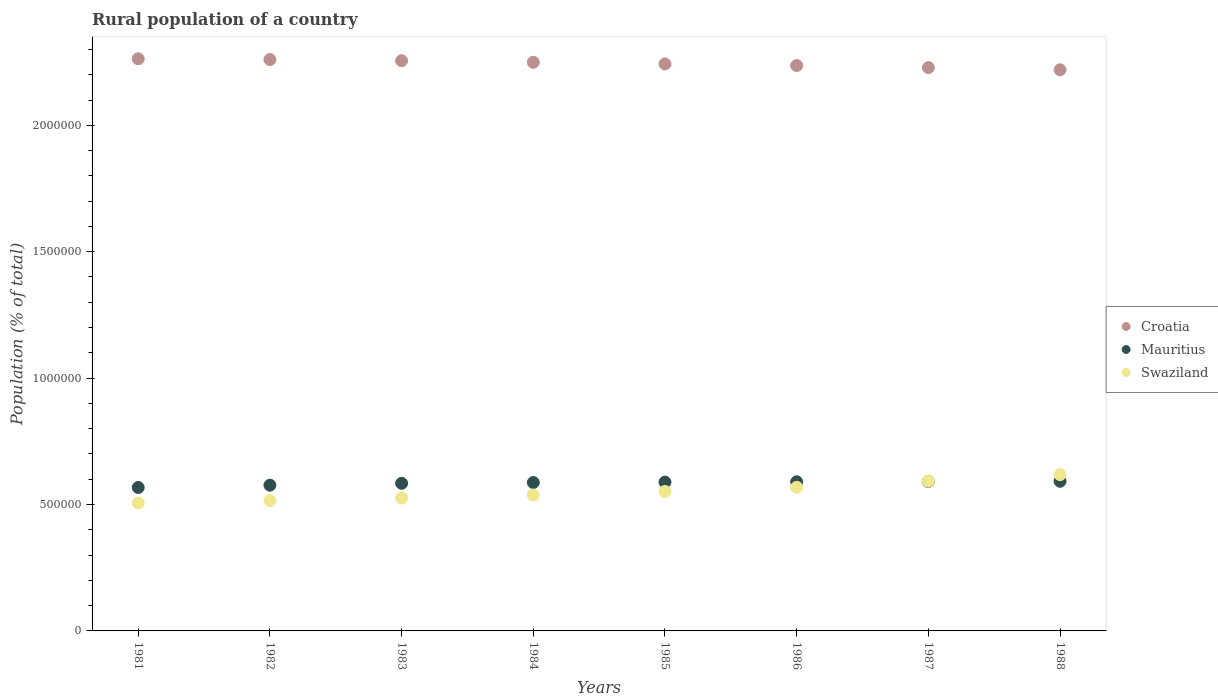How many different coloured dotlines are there?
Offer a terse response. 3. Is the number of dotlines equal to the number of legend labels?
Keep it short and to the point. Yes. What is the rural population in Mauritius in 1986?
Provide a short and direct response. 5.90e+05. Across all years, what is the maximum rural population in Swaziland?
Your answer should be compact. 6.18e+05. Across all years, what is the minimum rural population in Croatia?
Your answer should be very brief. 2.22e+06. In which year was the rural population in Swaziland maximum?
Offer a terse response. 1988. What is the total rural population in Swaziland in the graph?
Give a very brief answer. 4.42e+06. What is the difference between the rural population in Swaziland in 1982 and that in 1986?
Ensure brevity in your answer.  -5.27e+04. What is the difference between the rural population in Croatia in 1985 and the rural population in Mauritius in 1987?
Offer a very short reply. 1.65e+06. What is the average rural population in Croatia per year?
Offer a terse response. 2.24e+06. In the year 1985, what is the difference between the rural population in Croatia and rural population in Mauritius?
Provide a short and direct response. 1.65e+06. In how many years, is the rural population in Mauritius greater than 300000 %?
Offer a very short reply. 8. What is the ratio of the rural population in Swaziland in 1984 to that in 1988?
Give a very brief answer. 0.87. Is the rural population in Croatia in 1983 less than that in 1986?
Offer a terse response. No. What is the difference between the highest and the second highest rural population in Swaziland?
Make the answer very short. 2.60e+04. What is the difference between the highest and the lowest rural population in Swaziland?
Ensure brevity in your answer.  1.12e+05. In how many years, is the rural population in Croatia greater than the average rural population in Croatia taken over all years?
Offer a terse response. 4. Does the rural population in Croatia monotonically increase over the years?
Make the answer very short. No. Is the rural population in Croatia strictly greater than the rural population in Swaziland over the years?
Your answer should be compact. Yes. Is the rural population in Croatia strictly less than the rural population in Swaziland over the years?
Your response must be concise. No. Are the values on the major ticks of Y-axis written in scientific E-notation?
Offer a very short reply. No. Does the graph contain any zero values?
Offer a terse response. No. Does the graph contain grids?
Provide a short and direct response. No. How are the legend labels stacked?
Ensure brevity in your answer.  Vertical. What is the title of the graph?
Your answer should be very brief. Rural population of a country. What is the label or title of the X-axis?
Ensure brevity in your answer.  Years. What is the label or title of the Y-axis?
Make the answer very short. Population (% of total). What is the Population (% of total) in Croatia in 1981?
Offer a very short reply. 2.26e+06. What is the Population (% of total) in Mauritius in 1981?
Keep it short and to the point. 5.67e+05. What is the Population (% of total) in Swaziland in 1981?
Your answer should be compact. 5.06e+05. What is the Population (% of total) of Croatia in 1982?
Offer a very short reply. 2.26e+06. What is the Population (% of total) in Mauritius in 1982?
Ensure brevity in your answer.  5.76e+05. What is the Population (% of total) in Swaziland in 1982?
Your answer should be compact. 5.16e+05. What is the Population (% of total) in Croatia in 1983?
Ensure brevity in your answer.  2.26e+06. What is the Population (% of total) in Mauritius in 1983?
Make the answer very short. 5.84e+05. What is the Population (% of total) in Swaziland in 1983?
Provide a succinct answer. 5.26e+05. What is the Population (% of total) in Croatia in 1984?
Offer a terse response. 2.25e+06. What is the Population (% of total) of Mauritius in 1984?
Keep it short and to the point. 5.87e+05. What is the Population (% of total) in Swaziland in 1984?
Your answer should be very brief. 5.38e+05. What is the Population (% of total) in Croatia in 1985?
Offer a terse response. 2.24e+06. What is the Population (% of total) in Mauritius in 1985?
Make the answer very short. 5.89e+05. What is the Population (% of total) of Swaziland in 1985?
Give a very brief answer. 5.52e+05. What is the Population (% of total) of Croatia in 1986?
Give a very brief answer. 2.24e+06. What is the Population (% of total) of Mauritius in 1986?
Offer a terse response. 5.90e+05. What is the Population (% of total) in Swaziland in 1986?
Your answer should be compact. 5.68e+05. What is the Population (% of total) of Croatia in 1987?
Your answer should be very brief. 2.23e+06. What is the Population (% of total) of Mauritius in 1987?
Offer a terse response. 5.91e+05. What is the Population (% of total) in Swaziland in 1987?
Your answer should be compact. 5.92e+05. What is the Population (% of total) in Croatia in 1988?
Make the answer very short. 2.22e+06. What is the Population (% of total) of Mauritius in 1988?
Make the answer very short. 5.92e+05. What is the Population (% of total) of Swaziland in 1988?
Keep it short and to the point. 6.18e+05. Across all years, what is the maximum Population (% of total) in Croatia?
Your response must be concise. 2.26e+06. Across all years, what is the maximum Population (% of total) in Mauritius?
Your answer should be compact. 5.92e+05. Across all years, what is the maximum Population (% of total) of Swaziland?
Provide a succinct answer. 6.18e+05. Across all years, what is the minimum Population (% of total) in Croatia?
Give a very brief answer. 2.22e+06. Across all years, what is the minimum Population (% of total) of Mauritius?
Offer a terse response. 5.67e+05. Across all years, what is the minimum Population (% of total) of Swaziland?
Your answer should be very brief. 5.06e+05. What is the total Population (% of total) of Croatia in the graph?
Offer a very short reply. 1.80e+07. What is the total Population (% of total) of Mauritius in the graph?
Provide a succinct answer. 4.68e+06. What is the total Population (% of total) of Swaziland in the graph?
Your response must be concise. 4.42e+06. What is the difference between the Population (% of total) in Croatia in 1981 and that in 1982?
Ensure brevity in your answer.  3009. What is the difference between the Population (% of total) in Mauritius in 1981 and that in 1982?
Provide a succinct answer. -9132. What is the difference between the Population (% of total) of Swaziland in 1981 and that in 1982?
Your response must be concise. -9759. What is the difference between the Population (% of total) in Croatia in 1981 and that in 1983?
Your answer should be compact. 7659. What is the difference between the Population (% of total) of Mauritius in 1981 and that in 1983?
Your answer should be very brief. -1.66e+04. What is the difference between the Population (% of total) of Swaziland in 1981 and that in 1983?
Offer a very short reply. -2.00e+04. What is the difference between the Population (% of total) of Croatia in 1981 and that in 1984?
Your response must be concise. 1.39e+04. What is the difference between the Population (% of total) of Mauritius in 1981 and that in 1984?
Offer a very short reply. -1.96e+04. What is the difference between the Population (% of total) of Swaziland in 1981 and that in 1984?
Offer a terse response. -3.18e+04. What is the difference between the Population (% of total) in Croatia in 1981 and that in 1985?
Your answer should be very brief. 2.03e+04. What is the difference between the Population (% of total) of Mauritius in 1981 and that in 1985?
Your answer should be very brief. -2.12e+04. What is the difference between the Population (% of total) in Swaziland in 1981 and that in 1985?
Provide a succinct answer. -4.58e+04. What is the difference between the Population (% of total) of Croatia in 1981 and that in 1986?
Your answer should be very brief. 2.68e+04. What is the difference between the Population (% of total) of Mauritius in 1981 and that in 1986?
Provide a short and direct response. -2.25e+04. What is the difference between the Population (% of total) in Swaziland in 1981 and that in 1986?
Your answer should be very brief. -6.24e+04. What is the difference between the Population (% of total) in Croatia in 1981 and that in 1987?
Your response must be concise. 3.49e+04. What is the difference between the Population (% of total) of Mauritius in 1981 and that in 1987?
Offer a very short reply. -2.37e+04. What is the difference between the Population (% of total) of Swaziland in 1981 and that in 1987?
Give a very brief answer. -8.64e+04. What is the difference between the Population (% of total) in Croatia in 1981 and that in 1988?
Offer a terse response. 4.35e+04. What is the difference between the Population (% of total) of Mauritius in 1981 and that in 1988?
Your answer should be very brief. -2.45e+04. What is the difference between the Population (% of total) of Swaziland in 1981 and that in 1988?
Provide a short and direct response. -1.12e+05. What is the difference between the Population (% of total) of Croatia in 1982 and that in 1983?
Keep it short and to the point. 4650. What is the difference between the Population (% of total) of Mauritius in 1982 and that in 1983?
Keep it short and to the point. -7490. What is the difference between the Population (% of total) in Swaziland in 1982 and that in 1983?
Your response must be concise. -1.02e+04. What is the difference between the Population (% of total) of Croatia in 1982 and that in 1984?
Make the answer very short. 1.09e+04. What is the difference between the Population (% of total) of Mauritius in 1982 and that in 1984?
Keep it short and to the point. -1.05e+04. What is the difference between the Population (% of total) of Swaziland in 1982 and that in 1984?
Provide a succinct answer. -2.21e+04. What is the difference between the Population (% of total) of Croatia in 1982 and that in 1985?
Ensure brevity in your answer.  1.73e+04. What is the difference between the Population (% of total) of Mauritius in 1982 and that in 1985?
Provide a succinct answer. -1.21e+04. What is the difference between the Population (% of total) of Swaziland in 1982 and that in 1985?
Ensure brevity in your answer.  -3.61e+04. What is the difference between the Population (% of total) of Croatia in 1982 and that in 1986?
Offer a terse response. 2.38e+04. What is the difference between the Population (% of total) in Mauritius in 1982 and that in 1986?
Offer a terse response. -1.34e+04. What is the difference between the Population (% of total) in Swaziland in 1982 and that in 1986?
Offer a terse response. -5.27e+04. What is the difference between the Population (% of total) of Croatia in 1982 and that in 1987?
Your answer should be very brief. 3.18e+04. What is the difference between the Population (% of total) of Mauritius in 1982 and that in 1987?
Make the answer very short. -1.46e+04. What is the difference between the Population (% of total) in Swaziland in 1982 and that in 1987?
Keep it short and to the point. -7.67e+04. What is the difference between the Population (% of total) in Croatia in 1982 and that in 1988?
Offer a very short reply. 4.05e+04. What is the difference between the Population (% of total) in Mauritius in 1982 and that in 1988?
Offer a terse response. -1.54e+04. What is the difference between the Population (% of total) in Swaziland in 1982 and that in 1988?
Your response must be concise. -1.03e+05. What is the difference between the Population (% of total) of Croatia in 1983 and that in 1984?
Your answer should be compact. 6261. What is the difference between the Population (% of total) in Mauritius in 1983 and that in 1984?
Keep it short and to the point. -2991. What is the difference between the Population (% of total) of Swaziland in 1983 and that in 1984?
Your answer should be compact. -1.18e+04. What is the difference between the Population (% of total) of Croatia in 1983 and that in 1985?
Provide a succinct answer. 1.26e+04. What is the difference between the Population (% of total) in Mauritius in 1983 and that in 1985?
Keep it short and to the point. -4614. What is the difference between the Population (% of total) of Swaziland in 1983 and that in 1985?
Keep it short and to the point. -2.59e+04. What is the difference between the Population (% of total) in Croatia in 1983 and that in 1986?
Provide a succinct answer. 1.91e+04. What is the difference between the Population (% of total) in Mauritius in 1983 and that in 1986?
Offer a terse response. -5902. What is the difference between the Population (% of total) in Swaziland in 1983 and that in 1986?
Offer a terse response. -4.24e+04. What is the difference between the Population (% of total) of Croatia in 1983 and that in 1987?
Offer a terse response. 2.72e+04. What is the difference between the Population (% of total) in Mauritius in 1983 and that in 1987?
Your answer should be very brief. -7078. What is the difference between the Population (% of total) in Swaziland in 1983 and that in 1987?
Your answer should be compact. -6.64e+04. What is the difference between the Population (% of total) of Croatia in 1983 and that in 1988?
Make the answer very short. 3.59e+04. What is the difference between the Population (% of total) of Mauritius in 1983 and that in 1988?
Make the answer very short. -7864. What is the difference between the Population (% of total) in Swaziland in 1983 and that in 1988?
Offer a terse response. -9.24e+04. What is the difference between the Population (% of total) of Croatia in 1984 and that in 1985?
Make the answer very short. 6361. What is the difference between the Population (% of total) of Mauritius in 1984 and that in 1985?
Offer a terse response. -1623. What is the difference between the Population (% of total) of Swaziland in 1984 and that in 1985?
Ensure brevity in your answer.  -1.40e+04. What is the difference between the Population (% of total) of Croatia in 1984 and that in 1986?
Offer a terse response. 1.29e+04. What is the difference between the Population (% of total) in Mauritius in 1984 and that in 1986?
Your answer should be compact. -2911. What is the difference between the Population (% of total) in Swaziland in 1984 and that in 1986?
Provide a succinct answer. -3.06e+04. What is the difference between the Population (% of total) of Croatia in 1984 and that in 1987?
Your answer should be very brief. 2.09e+04. What is the difference between the Population (% of total) in Mauritius in 1984 and that in 1987?
Offer a terse response. -4087. What is the difference between the Population (% of total) in Swaziland in 1984 and that in 1987?
Make the answer very short. -5.46e+04. What is the difference between the Population (% of total) of Croatia in 1984 and that in 1988?
Keep it short and to the point. 2.96e+04. What is the difference between the Population (% of total) in Mauritius in 1984 and that in 1988?
Your answer should be compact. -4873. What is the difference between the Population (% of total) of Swaziland in 1984 and that in 1988?
Provide a short and direct response. -8.06e+04. What is the difference between the Population (% of total) in Croatia in 1985 and that in 1986?
Keep it short and to the point. 6508. What is the difference between the Population (% of total) in Mauritius in 1985 and that in 1986?
Keep it short and to the point. -1288. What is the difference between the Population (% of total) in Swaziland in 1985 and that in 1986?
Make the answer very short. -1.66e+04. What is the difference between the Population (% of total) in Croatia in 1985 and that in 1987?
Keep it short and to the point. 1.46e+04. What is the difference between the Population (% of total) in Mauritius in 1985 and that in 1987?
Offer a terse response. -2464. What is the difference between the Population (% of total) in Swaziland in 1985 and that in 1987?
Your response must be concise. -4.06e+04. What is the difference between the Population (% of total) in Croatia in 1985 and that in 1988?
Give a very brief answer. 2.32e+04. What is the difference between the Population (% of total) in Mauritius in 1985 and that in 1988?
Keep it short and to the point. -3250. What is the difference between the Population (% of total) of Swaziland in 1985 and that in 1988?
Offer a terse response. -6.66e+04. What is the difference between the Population (% of total) of Croatia in 1986 and that in 1987?
Offer a very short reply. 8065. What is the difference between the Population (% of total) in Mauritius in 1986 and that in 1987?
Keep it short and to the point. -1176. What is the difference between the Population (% of total) in Swaziland in 1986 and that in 1987?
Ensure brevity in your answer.  -2.40e+04. What is the difference between the Population (% of total) in Croatia in 1986 and that in 1988?
Provide a succinct answer. 1.67e+04. What is the difference between the Population (% of total) in Mauritius in 1986 and that in 1988?
Keep it short and to the point. -1962. What is the difference between the Population (% of total) of Swaziland in 1986 and that in 1988?
Keep it short and to the point. -5.00e+04. What is the difference between the Population (% of total) in Croatia in 1987 and that in 1988?
Provide a succinct answer. 8658. What is the difference between the Population (% of total) in Mauritius in 1987 and that in 1988?
Offer a terse response. -786. What is the difference between the Population (% of total) of Swaziland in 1987 and that in 1988?
Your response must be concise. -2.60e+04. What is the difference between the Population (% of total) of Croatia in 1981 and the Population (% of total) of Mauritius in 1982?
Keep it short and to the point. 1.69e+06. What is the difference between the Population (% of total) in Croatia in 1981 and the Population (% of total) in Swaziland in 1982?
Provide a short and direct response. 1.75e+06. What is the difference between the Population (% of total) of Mauritius in 1981 and the Population (% of total) of Swaziland in 1982?
Keep it short and to the point. 5.18e+04. What is the difference between the Population (% of total) of Croatia in 1981 and the Population (% of total) of Mauritius in 1983?
Make the answer very short. 1.68e+06. What is the difference between the Population (% of total) in Croatia in 1981 and the Population (% of total) in Swaziland in 1983?
Your answer should be compact. 1.74e+06. What is the difference between the Population (% of total) in Mauritius in 1981 and the Population (% of total) in Swaziland in 1983?
Offer a terse response. 4.15e+04. What is the difference between the Population (% of total) in Croatia in 1981 and the Population (% of total) in Mauritius in 1984?
Provide a short and direct response. 1.68e+06. What is the difference between the Population (% of total) in Croatia in 1981 and the Population (% of total) in Swaziland in 1984?
Keep it short and to the point. 1.73e+06. What is the difference between the Population (% of total) in Mauritius in 1981 and the Population (% of total) in Swaziland in 1984?
Provide a succinct answer. 2.97e+04. What is the difference between the Population (% of total) of Croatia in 1981 and the Population (% of total) of Mauritius in 1985?
Offer a terse response. 1.67e+06. What is the difference between the Population (% of total) in Croatia in 1981 and the Population (% of total) in Swaziland in 1985?
Provide a succinct answer. 1.71e+06. What is the difference between the Population (% of total) in Mauritius in 1981 and the Population (% of total) in Swaziland in 1985?
Your response must be concise. 1.57e+04. What is the difference between the Population (% of total) of Croatia in 1981 and the Population (% of total) of Mauritius in 1986?
Your answer should be very brief. 1.67e+06. What is the difference between the Population (% of total) of Croatia in 1981 and the Population (% of total) of Swaziland in 1986?
Ensure brevity in your answer.  1.69e+06. What is the difference between the Population (% of total) in Mauritius in 1981 and the Population (% of total) in Swaziland in 1986?
Ensure brevity in your answer.  -874. What is the difference between the Population (% of total) of Croatia in 1981 and the Population (% of total) of Mauritius in 1987?
Your answer should be very brief. 1.67e+06. What is the difference between the Population (% of total) of Croatia in 1981 and the Population (% of total) of Swaziland in 1987?
Ensure brevity in your answer.  1.67e+06. What is the difference between the Population (% of total) in Mauritius in 1981 and the Population (% of total) in Swaziland in 1987?
Your answer should be compact. -2.49e+04. What is the difference between the Population (% of total) in Croatia in 1981 and the Population (% of total) in Mauritius in 1988?
Provide a short and direct response. 1.67e+06. What is the difference between the Population (% of total) of Croatia in 1981 and the Population (% of total) of Swaziland in 1988?
Provide a succinct answer. 1.64e+06. What is the difference between the Population (% of total) in Mauritius in 1981 and the Population (% of total) in Swaziland in 1988?
Provide a succinct answer. -5.09e+04. What is the difference between the Population (% of total) in Croatia in 1982 and the Population (% of total) in Mauritius in 1983?
Your answer should be very brief. 1.68e+06. What is the difference between the Population (% of total) of Croatia in 1982 and the Population (% of total) of Swaziland in 1983?
Ensure brevity in your answer.  1.73e+06. What is the difference between the Population (% of total) of Mauritius in 1982 and the Population (% of total) of Swaziland in 1983?
Your answer should be very brief. 5.07e+04. What is the difference between the Population (% of total) in Croatia in 1982 and the Population (% of total) in Mauritius in 1984?
Your answer should be very brief. 1.67e+06. What is the difference between the Population (% of total) in Croatia in 1982 and the Population (% of total) in Swaziland in 1984?
Your answer should be very brief. 1.72e+06. What is the difference between the Population (% of total) in Mauritius in 1982 and the Population (% of total) in Swaziland in 1984?
Offer a very short reply. 3.88e+04. What is the difference between the Population (% of total) in Croatia in 1982 and the Population (% of total) in Mauritius in 1985?
Your answer should be very brief. 1.67e+06. What is the difference between the Population (% of total) in Croatia in 1982 and the Population (% of total) in Swaziland in 1985?
Keep it short and to the point. 1.71e+06. What is the difference between the Population (% of total) of Mauritius in 1982 and the Population (% of total) of Swaziland in 1985?
Give a very brief answer. 2.48e+04. What is the difference between the Population (% of total) in Croatia in 1982 and the Population (% of total) in Mauritius in 1986?
Keep it short and to the point. 1.67e+06. What is the difference between the Population (% of total) of Croatia in 1982 and the Population (% of total) of Swaziland in 1986?
Offer a very short reply. 1.69e+06. What is the difference between the Population (% of total) in Mauritius in 1982 and the Population (% of total) in Swaziland in 1986?
Provide a succinct answer. 8258. What is the difference between the Population (% of total) in Croatia in 1982 and the Population (% of total) in Mauritius in 1987?
Provide a short and direct response. 1.67e+06. What is the difference between the Population (% of total) in Croatia in 1982 and the Population (% of total) in Swaziland in 1987?
Ensure brevity in your answer.  1.67e+06. What is the difference between the Population (% of total) in Mauritius in 1982 and the Population (% of total) in Swaziland in 1987?
Provide a short and direct response. -1.58e+04. What is the difference between the Population (% of total) in Croatia in 1982 and the Population (% of total) in Mauritius in 1988?
Give a very brief answer. 1.67e+06. What is the difference between the Population (% of total) in Croatia in 1982 and the Population (% of total) in Swaziland in 1988?
Offer a terse response. 1.64e+06. What is the difference between the Population (% of total) of Mauritius in 1982 and the Population (% of total) of Swaziland in 1988?
Your answer should be very brief. -4.17e+04. What is the difference between the Population (% of total) in Croatia in 1983 and the Population (% of total) in Mauritius in 1984?
Ensure brevity in your answer.  1.67e+06. What is the difference between the Population (% of total) of Croatia in 1983 and the Population (% of total) of Swaziland in 1984?
Your response must be concise. 1.72e+06. What is the difference between the Population (% of total) in Mauritius in 1983 and the Population (% of total) in Swaziland in 1984?
Your answer should be very brief. 4.63e+04. What is the difference between the Population (% of total) of Croatia in 1983 and the Population (% of total) of Mauritius in 1985?
Give a very brief answer. 1.67e+06. What is the difference between the Population (% of total) in Croatia in 1983 and the Population (% of total) in Swaziland in 1985?
Your answer should be very brief. 1.70e+06. What is the difference between the Population (% of total) in Mauritius in 1983 and the Population (% of total) in Swaziland in 1985?
Your answer should be compact. 3.23e+04. What is the difference between the Population (% of total) of Croatia in 1983 and the Population (% of total) of Mauritius in 1986?
Offer a terse response. 1.67e+06. What is the difference between the Population (% of total) of Croatia in 1983 and the Population (% of total) of Swaziland in 1986?
Keep it short and to the point. 1.69e+06. What is the difference between the Population (% of total) in Mauritius in 1983 and the Population (% of total) in Swaziland in 1986?
Give a very brief answer. 1.57e+04. What is the difference between the Population (% of total) of Croatia in 1983 and the Population (% of total) of Mauritius in 1987?
Ensure brevity in your answer.  1.66e+06. What is the difference between the Population (% of total) of Croatia in 1983 and the Population (% of total) of Swaziland in 1987?
Make the answer very short. 1.66e+06. What is the difference between the Population (% of total) in Mauritius in 1983 and the Population (% of total) in Swaziland in 1987?
Your response must be concise. -8286. What is the difference between the Population (% of total) of Croatia in 1983 and the Population (% of total) of Mauritius in 1988?
Ensure brevity in your answer.  1.66e+06. What is the difference between the Population (% of total) in Croatia in 1983 and the Population (% of total) in Swaziland in 1988?
Make the answer very short. 1.64e+06. What is the difference between the Population (% of total) in Mauritius in 1983 and the Population (% of total) in Swaziland in 1988?
Your answer should be compact. -3.42e+04. What is the difference between the Population (% of total) of Croatia in 1984 and the Population (% of total) of Mauritius in 1985?
Provide a short and direct response. 1.66e+06. What is the difference between the Population (% of total) in Croatia in 1984 and the Population (% of total) in Swaziland in 1985?
Your response must be concise. 1.70e+06. What is the difference between the Population (% of total) in Mauritius in 1984 and the Population (% of total) in Swaziland in 1985?
Ensure brevity in your answer.  3.53e+04. What is the difference between the Population (% of total) of Croatia in 1984 and the Population (% of total) of Mauritius in 1986?
Your answer should be compact. 1.66e+06. What is the difference between the Population (% of total) in Croatia in 1984 and the Population (% of total) in Swaziland in 1986?
Provide a short and direct response. 1.68e+06. What is the difference between the Population (% of total) of Mauritius in 1984 and the Population (% of total) of Swaziland in 1986?
Keep it short and to the point. 1.87e+04. What is the difference between the Population (% of total) of Croatia in 1984 and the Population (% of total) of Mauritius in 1987?
Provide a succinct answer. 1.66e+06. What is the difference between the Population (% of total) of Croatia in 1984 and the Population (% of total) of Swaziland in 1987?
Your response must be concise. 1.66e+06. What is the difference between the Population (% of total) in Mauritius in 1984 and the Population (% of total) in Swaziland in 1987?
Your response must be concise. -5295. What is the difference between the Population (% of total) of Croatia in 1984 and the Population (% of total) of Mauritius in 1988?
Provide a short and direct response. 1.66e+06. What is the difference between the Population (% of total) of Croatia in 1984 and the Population (% of total) of Swaziland in 1988?
Give a very brief answer. 1.63e+06. What is the difference between the Population (% of total) in Mauritius in 1984 and the Population (% of total) in Swaziland in 1988?
Your response must be concise. -3.13e+04. What is the difference between the Population (% of total) of Croatia in 1985 and the Population (% of total) of Mauritius in 1986?
Provide a short and direct response. 1.65e+06. What is the difference between the Population (% of total) of Croatia in 1985 and the Population (% of total) of Swaziland in 1986?
Make the answer very short. 1.67e+06. What is the difference between the Population (% of total) in Mauritius in 1985 and the Population (% of total) in Swaziland in 1986?
Offer a terse response. 2.04e+04. What is the difference between the Population (% of total) of Croatia in 1985 and the Population (% of total) of Mauritius in 1987?
Your answer should be very brief. 1.65e+06. What is the difference between the Population (% of total) in Croatia in 1985 and the Population (% of total) in Swaziland in 1987?
Your answer should be very brief. 1.65e+06. What is the difference between the Population (% of total) in Mauritius in 1985 and the Population (% of total) in Swaziland in 1987?
Your response must be concise. -3672. What is the difference between the Population (% of total) of Croatia in 1985 and the Population (% of total) of Mauritius in 1988?
Your answer should be compact. 1.65e+06. What is the difference between the Population (% of total) of Croatia in 1985 and the Population (% of total) of Swaziland in 1988?
Ensure brevity in your answer.  1.62e+06. What is the difference between the Population (% of total) in Mauritius in 1985 and the Population (% of total) in Swaziland in 1988?
Ensure brevity in your answer.  -2.96e+04. What is the difference between the Population (% of total) of Croatia in 1986 and the Population (% of total) of Mauritius in 1987?
Keep it short and to the point. 1.65e+06. What is the difference between the Population (% of total) in Croatia in 1986 and the Population (% of total) in Swaziland in 1987?
Your response must be concise. 1.64e+06. What is the difference between the Population (% of total) in Mauritius in 1986 and the Population (% of total) in Swaziland in 1987?
Ensure brevity in your answer.  -2384. What is the difference between the Population (% of total) of Croatia in 1986 and the Population (% of total) of Mauritius in 1988?
Offer a very short reply. 1.64e+06. What is the difference between the Population (% of total) of Croatia in 1986 and the Population (% of total) of Swaziland in 1988?
Your answer should be very brief. 1.62e+06. What is the difference between the Population (% of total) in Mauritius in 1986 and the Population (% of total) in Swaziland in 1988?
Make the answer very short. -2.83e+04. What is the difference between the Population (% of total) in Croatia in 1987 and the Population (% of total) in Mauritius in 1988?
Provide a short and direct response. 1.64e+06. What is the difference between the Population (% of total) in Croatia in 1987 and the Population (% of total) in Swaziland in 1988?
Offer a very short reply. 1.61e+06. What is the difference between the Population (% of total) in Mauritius in 1987 and the Population (% of total) in Swaziland in 1988?
Offer a terse response. -2.72e+04. What is the average Population (% of total) in Croatia per year?
Make the answer very short. 2.24e+06. What is the average Population (% of total) of Mauritius per year?
Your answer should be compact. 5.85e+05. What is the average Population (% of total) in Swaziland per year?
Offer a very short reply. 5.52e+05. In the year 1981, what is the difference between the Population (% of total) in Croatia and Population (% of total) in Mauritius?
Offer a very short reply. 1.70e+06. In the year 1981, what is the difference between the Population (% of total) in Croatia and Population (% of total) in Swaziland?
Make the answer very short. 1.76e+06. In the year 1981, what is the difference between the Population (% of total) of Mauritius and Population (% of total) of Swaziland?
Your answer should be very brief. 6.15e+04. In the year 1982, what is the difference between the Population (% of total) in Croatia and Population (% of total) in Mauritius?
Offer a very short reply. 1.68e+06. In the year 1982, what is the difference between the Population (% of total) of Croatia and Population (% of total) of Swaziland?
Ensure brevity in your answer.  1.74e+06. In the year 1982, what is the difference between the Population (% of total) in Mauritius and Population (% of total) in Swaziland?
Your response must be concise. 6.09e+04. In the year 1983, what is the difference between the Population (% of total) in Croatia and Population (% of total) in Mauritius?
Provide a short and direct response. 1.67e+06. In the year 1983, what is the difference between the Population (% of total) of Croatia and Population (% of total) of Swaziland?
Make the answer very short. 1.73e+06. In the year 1983, what is the difference between the Population (% of total) in Mauritius and Population (% of total) in Swaziland?
Your response must be concise. 5.82e+04. In the year 1984, what is the difference between the Population (% of total) of Croatia and Population (% of total) of Mauritius?
Provide a short and direct response. 1.66e+06. In the year 1984, what is the difference between the Population (% of total) in Croatia and Population (% of total) in Swaziland?
Make the answer very short. 1.71e+06. In the year 1984, what is the difference between the Population (% of total) in Mauritius and Population (% of total) in Swaziland?
Provide a short and direct response. 4.93e+04. In the year 1985, what is the difference between the Population (% of total) in Croatia and Population (% of total) in Mauritius?
Your response must be concise. 1.65e+06. In the year 1985, what is the difference between the Population (% of total) of Croatia and Population (% of total) of Swaziland?
Offer a very short reply. 1.69e+06. In the year 1985, what is the difference between the Population (% of total) of Mauritius and Population (% of total) of Swaziland?
Offer a terse response. 3.69e+04. In the year 1986, what is the difference between the Population (% of total) of Croatia and Population (% of total) of Mauritius?
Make the answer very short. 1.65e+06. In the year 1986, what is the difference between the Population (% of total) in Croatia and Population (% of total) in Swaziland?
Your answer should be very brief. 1.67e+06. In the year 1986, what is the difference between the Population (% of total) in Mauritius and Population (% of total) in Swaziland?
Your response must be concise. 2.16e+04. In the year 1987, what is the difference between the Population (% of total) of Croatia and Population (% of total) of Mauritius?
Your answer should be very brief. 1.64e+06. In the year 1987, what is the difference between the Population (% of total) of Croatia and Population (% of total) of Swaziland?
Provide a succinct answer. 1.64e+06. In the year 1987, what is the difference between the Population (% of total) of Mauritius and Population (% of total) of Swaziland?
Offer a terse response. -1208. In the year 1988, what is the difference between the Population (% of total) in Croatia and Population (% of total) in Mauritius?
Your response must be concise. 1.63e+06. In the year 1988, what is the difference between the Population (% of total) in Croatia and Population (% of total) in Swaziland?
Provide a short and direct response. 1.60e+06. In the year 1988, what is the difference between the Population (% of total) of Mauritius and Population (% of total) of Swaziland?
Give a very brief answer. -2.64e+04. What is the ratio of the Population (% of total) of Mauritius in 1981 to that in 1982?
Provide a succinct answer. 0.98. What is the ratio of the Population (% of total) in Swaziland in 1981 to that in 1982?
Your response must be concise. 0.98. What is the ratio of the Population (% of total) in Croatia in 1981 to that in 1983?
Keep it short and to the point. 1. What is the ratio of the Population (% of total) of Mauritius in 1981 to that in 1983?
Give a very brief answer. 0.97. What is the ratio of the Population (% of total) in Swaziland in 1981 to that in 1983?
Ensure brevity in your answer.  0.96. What is the ratio of the Population (% of total) of Croatia in 1981 to that in 1984?
Keep it short and to the point. 1.01. What is the ratio of the Population (% of total) in Mauritius in 1981 to that in 1984?
Your answer should be compact. 0.97. What is the ratio of the Population (% of total) in Swaziland in 1981 to that in 1984?
Offer a very short reply. 0.94. What is the ratio of the Population (% of total) in Mauritius in 1981 to that in 1985?
Offer a terse response. 0.96. What is the ratio of the Population (% of total) in Swaziland in 1981 to that in 1985?
Your answer should be very brief. 0.92. What is the ratio of the Population (% of total) in Mauritius in 1981 to that in 1986?
Offer a terse response. 0.96. What is the ratio of the Population (% of total) in Swaziland in 1981 to that in 1986?
Keep it short and to the point. 0.89. What is the ratio of the Population (% of total) in Croatia in 1981 to that in 1987?
Make the answer very short. 1.02. What is the ratio of the Population (% of total) in Mauritius in 1981 to that in 1987?
Your answer should be compact. 0.96. What is the ratio of the Population (% of total) of Swaziland in 1981 to that in 1987?
Offer a terse response. 0.85. What is the ratio of the Population (% of total) in Croatia in 1981 to that in 1988?
Offer a terse response. 1.02. What is the ratio of the Population (% of total) in Mauritius in 1981 to that in 1988?
Offer a terse response. 0.96. What is the ratio of the Population (% of total) in Swaziland in 1981 to that in 1988?
Ensure brevity in your answer.  0.82. What is the ratio of the Population (% of total) of Mauritius in 1982 to that in 1983?
Provide a succinct answer. 0.99. What is the ratio of the Population (% of total) in Swaziland in 1982 to that in 1983?
Your answer should be compact. 0.98. What is the ratio of the Population (% of total) of Croatia in 1982 to that in 1984?
Your answer should be very brief. 1. What is the ratio of the Population (% of total) in Mauritius in 1982 to that in 1984?
Provide a short and direct response. 0.98. What is the ratio of the Population (% of total) in Croatia in 1982 to that in 1985?
Offer a terse response. 1.01. What is the ratio of the Population (% of total) of Mauritius in 1982 to that in 1985?
Your answer should be very brief. 0.98. What is the ratio of the Population (% of total) in Swaziland in 1982 to that in 1985?
Offer a very short reply. 0.93. What is the ratio of the Population (% of total) in Croatia in 1982 to that in 1986?
Your answer should be compact. 1.01. What is the ratio of the Population (% of total) in Mauritius in 1982 to that in 1986?
Provide a short and direct response. 0.98. What is the ratio of the Population (% of total) in Swaziland in 1982 to that in 1986?
Keep it short and to the point. 0.91. What is the ratio of the Population (% of total) of Croatia in 1982 to that in 1987?
Your answer should be compact. 1.01. What is the ratio of the Population (% of total) of Mauritius in 1982 to that in 1987?
Your response must be concise. 0.98. What is the ratio of the Population (% of total) of Swaziland in 1982 to that in 1987?
Provide a succinct answer. 0.87. What is the ratio of the Population (% of total) in Croatia in 1982 to that in 1988?
Your response must be concise. 1.02. What is the ratio of the Population (% of total) of Mauritius in 1982 to that in 1988?
Ensure brevity in your answer.  0.97. What is the ratio of the Population (% of total) of Swaziland in 1982 to that in 1988?
Offer a very short reply. 0.83. What is the ratio of the Population (% of total) in Mauritius in 1983 to that in 1984?
Your answer should be compact. 0.99. What is the ratio of the Population (% of total) in Swaziland in 1983 to that in 1984?
Your response must be concise. 0.98. What is the ratio of the Population (% of total) of Croatia in 1983 to that in 1985?
Give a very brief answer. 1.01. What is the ratio of the Population (% of total) of Mauritius in 1983 to that in 1985?
Give a very brief answer. 0.99. What is the ratio of the Population (% of total) of Swaziland in 1983 to that in 1985?
Your answer should be very brief. 0.95. What is the ratio of the Population (% of total) in Croatia in 1983 to that in 1986?
Your answer should be very brief. 1.01. What is the ratio of the Population (% of total) of Swaziland in 1983 to that in 1986?
Your answer should be compact. 0.93. What is the ratio of the Population (% of total) in Croatia in 1983 to that in 1987?
Your answer should be compact. 1.01. What is the ratio of the Population (% of total) in Swaziland in 1983 to that in 1987?
Your response must be concise. 0.89. What is the ratio of the Population (% of total) in Croatia in 1983 to that in 1988?
Your answer should be very brief. 1.02. What is the ratio of the Population (% of total) of Mauritius in 1983 to that in 1988?
Keep it short and to the point. 0.99. What is the ratio of the Population (% of total) in Swaziland in 1983 to that in 1988?
Ensure brevity in your answer.  0.85. What is the ratio of the Population (% of total) of Croatia in 1984 to that in 1985?
Your answer should be very brief. 1. What is the ratio of the Population (% of total) in Swaziland in 1984 to that in 1985?
Provide a short and direct response. 0.97. What is the ratio of the Population (% of total) in Croatia in 1984 to that in 1986?
Offer a very short reply. 1.01. What is the ratio of the Population (% of total) of Mauritius in 1984 to that in 1986?
Ensure brevity in your answer.  1. What is the ratio of the Population (% of total) of Swaziland in 1984 to that in 1986?
Your answer should be compact. 0.95. What is the ratio of the Population (% of total) of Croatia in 1984 to that in 1987?
Keep it short and to the point. 1.01. What is the ratio of the Population (% of total) in Mauritius in 1984 to that in 1987?
Ensure brevity in your answer.  0.99. What is the ratio of the Population (% of total) of Swaziland in 1984 to that in 1987?
Provide a short and direct response. 0.91. What is the ratio of the Population (% of total) in Croatia in 1984 to that in 1988?
Ensure brevity in your answer.  1.01. What is the ratio of the Population (% of total) of Mauritius in 1984 to that in 1988?
Your answer should be compact. 0.99. What is the ratio of the Population (% of total) of Swaziland in 1984 to that in 1988?
Provide a succinct answer. 0.87. What is the ratio of the Population (% of total) in Swaziland in 1985 to that in 1986?
Your response must be concise. 0.97. What is the ratio of the Population (% of total) of Mauritius in 1985 to that in 1987?
Your answer should be compact. 1. What is the ratio of the Population (% of total) of Swaziland in 1985 to that in 1987?
Your response must be concise. 0.93. What is the ratio of the Population (% of total) of Croatia in 1985 to that in 1988?
Your answer should be compact. 1.01. What is the ratio of the Population (% of total) in Swaziland in 1985 to that in 1988?
Keep it short and to the point. 0.89. What is the ratio of the Population (% of total) in Croatia in 1986 to that in 1987?
Offer a very short reply. 1. What is the ratio of the Population (% of total) in Mauritius in 1986 to that in 1987?
Provide a short and direct response. 1. What is the ratio of the Population (% of total) of Swaziland in 1986 to that in 1987?
Provide a succinct answer. 0.96. What is the ratio of the Population (% of total) in Croatia in 1986 to that in 1988?
Provide a succinct answer. 1.01. What is the ratio of the Population (% of total) of Swaziland in 1986 to that in 1988?
Make the answer very short. 0.92. What is the ratio of the Population (% of total) in Mauritius in 1987 to that in 1988?
Your response must be concise. 1. What is the ratio of the Population (% of total) of Swaziland in 1987 to that in 1988?
Your response must be concise. 0.96. What is the difference between the highest and the second highest Population (% of total) in Croatia?
Keep it short and to the point. 3009. What is the difference between the highest and the second highest Population (% of total) of Mauritius?
Provide a succinct answer. 786. What is the difference between the highest and the second highest Population (% of total) of Swaziland?
Make the answer very short. 2.60e+04. What is the difference between the highest and the lowest Population (% of total) of Croatia?
Make the answer very short. 4.35e+04. What is the difference between the highest and the lowest Population (% of total) in Mauritius?
Your response must be concise. 2.45e+04. What is the difference between the highest and the lowest Population (% of total) in Swaziland?
Your answer should be very brief. 1.12e+05. 